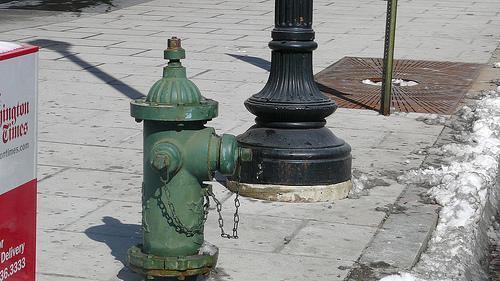How many fire hydrants are in the picture?
Give a very brief answer. 1. 